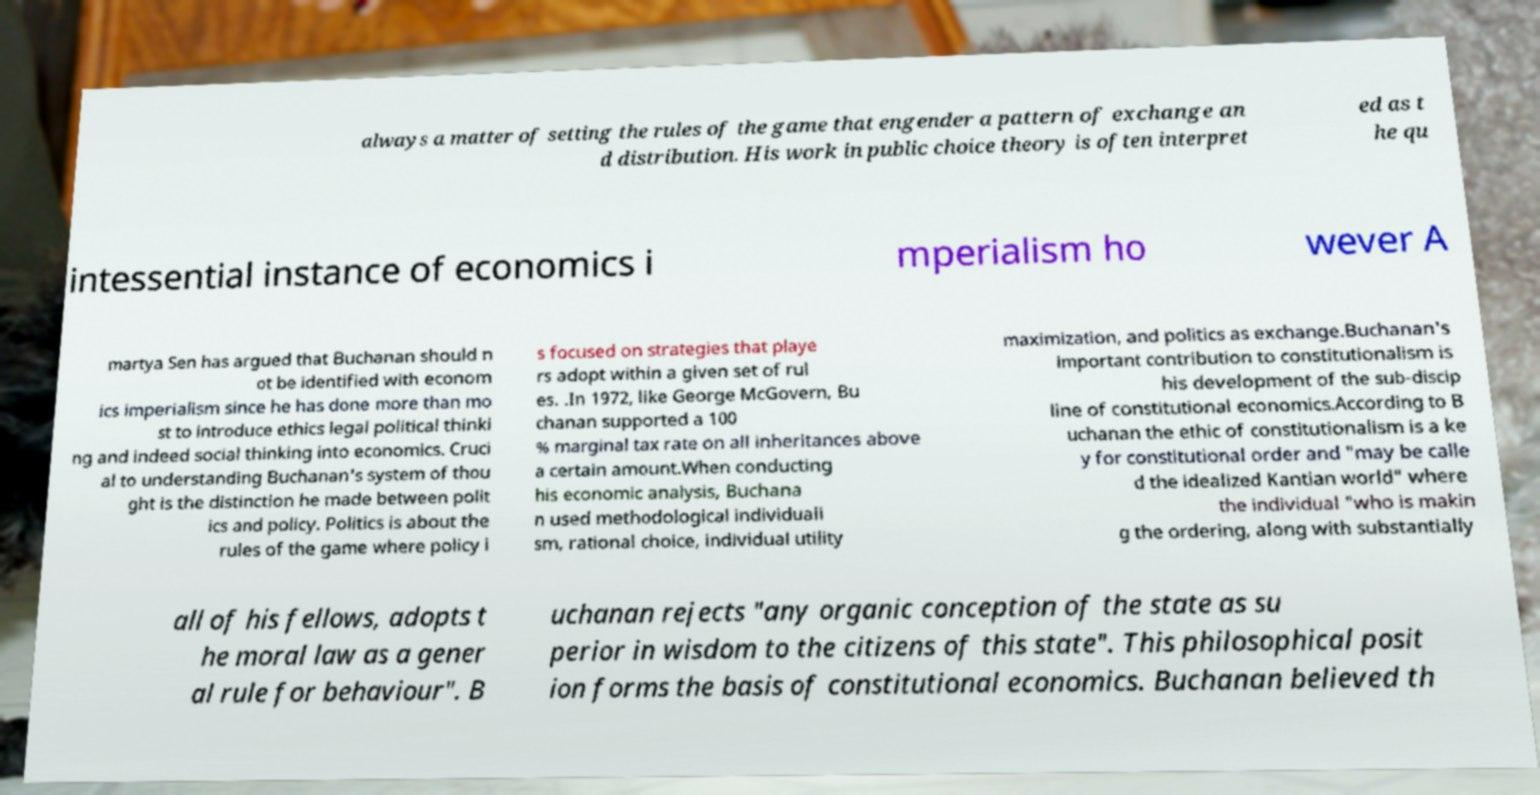For documentation purposes, I need the text within this image transcribed. Could you provide that? always a matter of setting the rules of the game that engender a pattern of exchange an d distribution. His work in public choice theory is often interpret ed as t he qu intessential instance of economics i mperialism ho wever A martya Sen has argued that Buchanan should n ot be identified with econom ics imperialism since he has done more than mo st to introduce ethics legal political thinki ng and indeed social thinking into economics. Cruci al to understanding Buchanan's system of thou ght is the distinction he made between polit ics and policy. Politics is about the rules of the game where policy i s focused on strategies that playe rs adopt within a given set of rul es. .In 1972, like George McGovern, Bu chanan supported a 100 % marginal tax rate on all inheritances above a certain amount.When conducting his economic analysis, Buchana n used methodological individuali sm, rational choice, individual utility maximization, and politics as exchange.Buchanan's important contribution to constitutionalism is his development of the sub-discip line of constitutional economics.According to B uchanan the ethic of constitutionalism is a ke y for constitutional order and "may be calle d the idealized Kantian world" where the individual "who is makin g the ordering, along with substantially all of his fellows, adopts t he moral law as a gener al rule for behaviour". B uchanan rejects "any organic conception of the state as su perior in wisdom to the citizens of this state". This philosophical posit ion forms the basis of constitutional economics. Buchanan believed th 